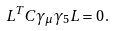Convert formula to latex. <formula><loc_0><loc_0><loc_500><loc_500>L ^ { T } C \gamma _ { \mu } \gamma _ { 5 } L = 0 \, .</formula> 